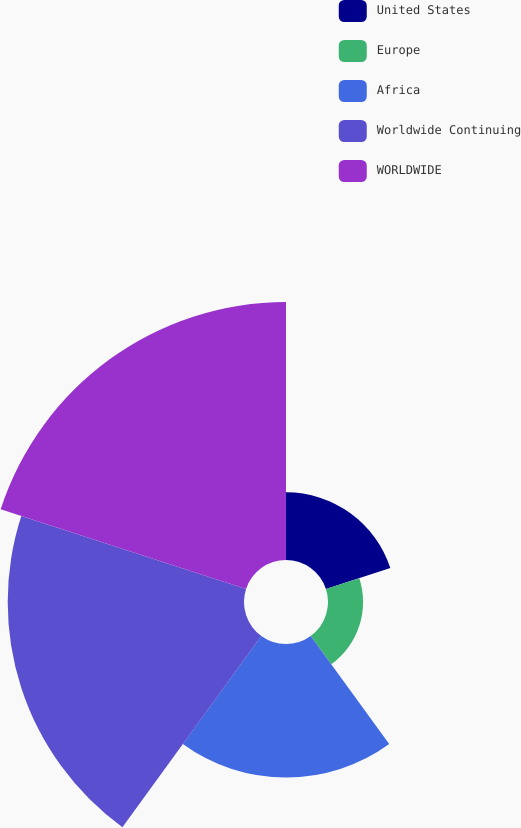<chart> <loc_0><loc_0><loc_500><loc_500><pie_chart><fcel>United States<fcel>Europe<fcel>Africa<fcel>Worldwide Continuing<fcel>WORLDWIDE<nl><fcel>9.26%<fcel>4.8%<fcel>18.28%<fcel>32.34%<fcel>35.31%<nl></chart> 